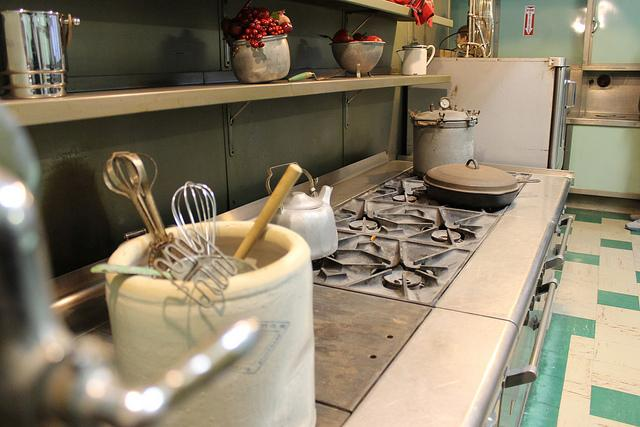What could the pot with the round white gauge on top be used for? tea 